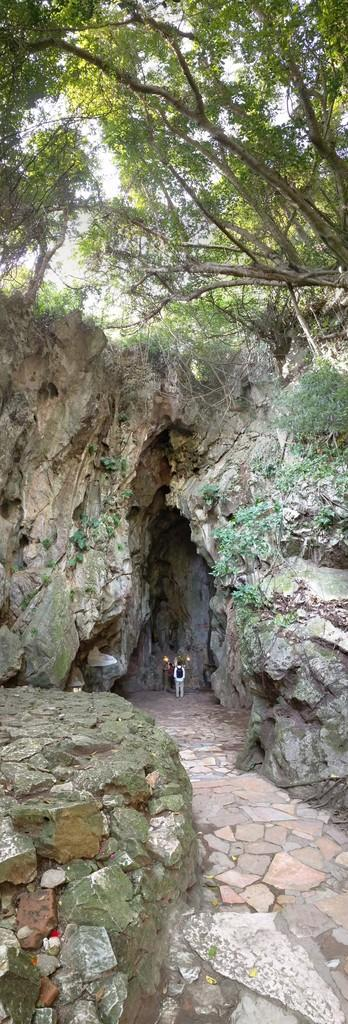What is happening in the image? There are people standing in the image. Where are the people standing? The people are standing on the floor. What can be seen in the background of the image? There are rocks in the background of the image, and creeper plants are present on the rocks. What is visible at the top of the image? There are trees and plants visible at the top of the image. How does the home in the image help the people? There is no home present in the image; it only shows people standing on the floor with rocks, creeper plants, trees, and plants in the background. 